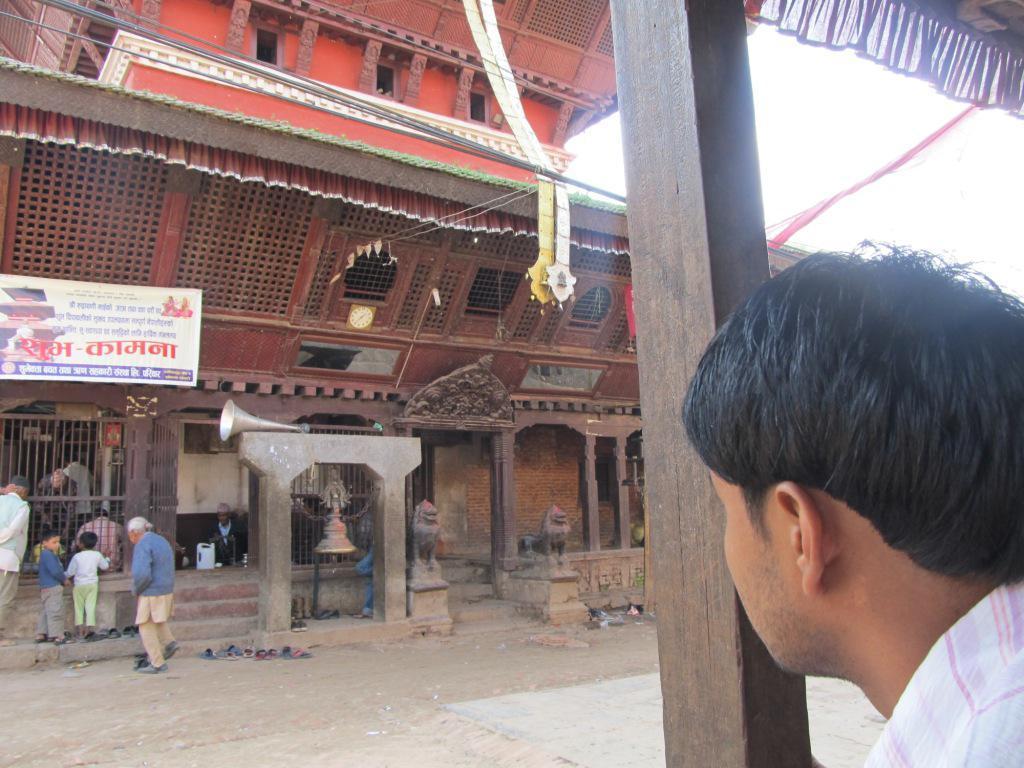Please provide a concise description of this image. On the right side of the image there is a person, in front of the person there is a wooden pole. On the left side of the image there is a building, in front of the building there are some people stranding. 